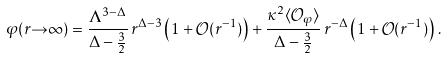Convert formula to latex. <formula><loc_0><loc_0><loc_500><loc_500>\varphi ( r { \to } \infty ) = \frac { \Lambda ^ { 3 - \Delta } } { \Delta - \frac { 3 } { 2 } } \, r ^ { \Delta - 3 } \left ( 1 + \mathcal { O } ( r ^ { - 1 } ) \right ) + \frac { \kappa ^ { 2 } \langle \mathcal { O } _ { \varphi } \rangle } { \Delta - \frac { 3 } { 2 } } \, r ^ { - \Delta } \left ( 1 + \mathcal { O } ( r ^ { - 1 } ) \right ) \, .</formula> 